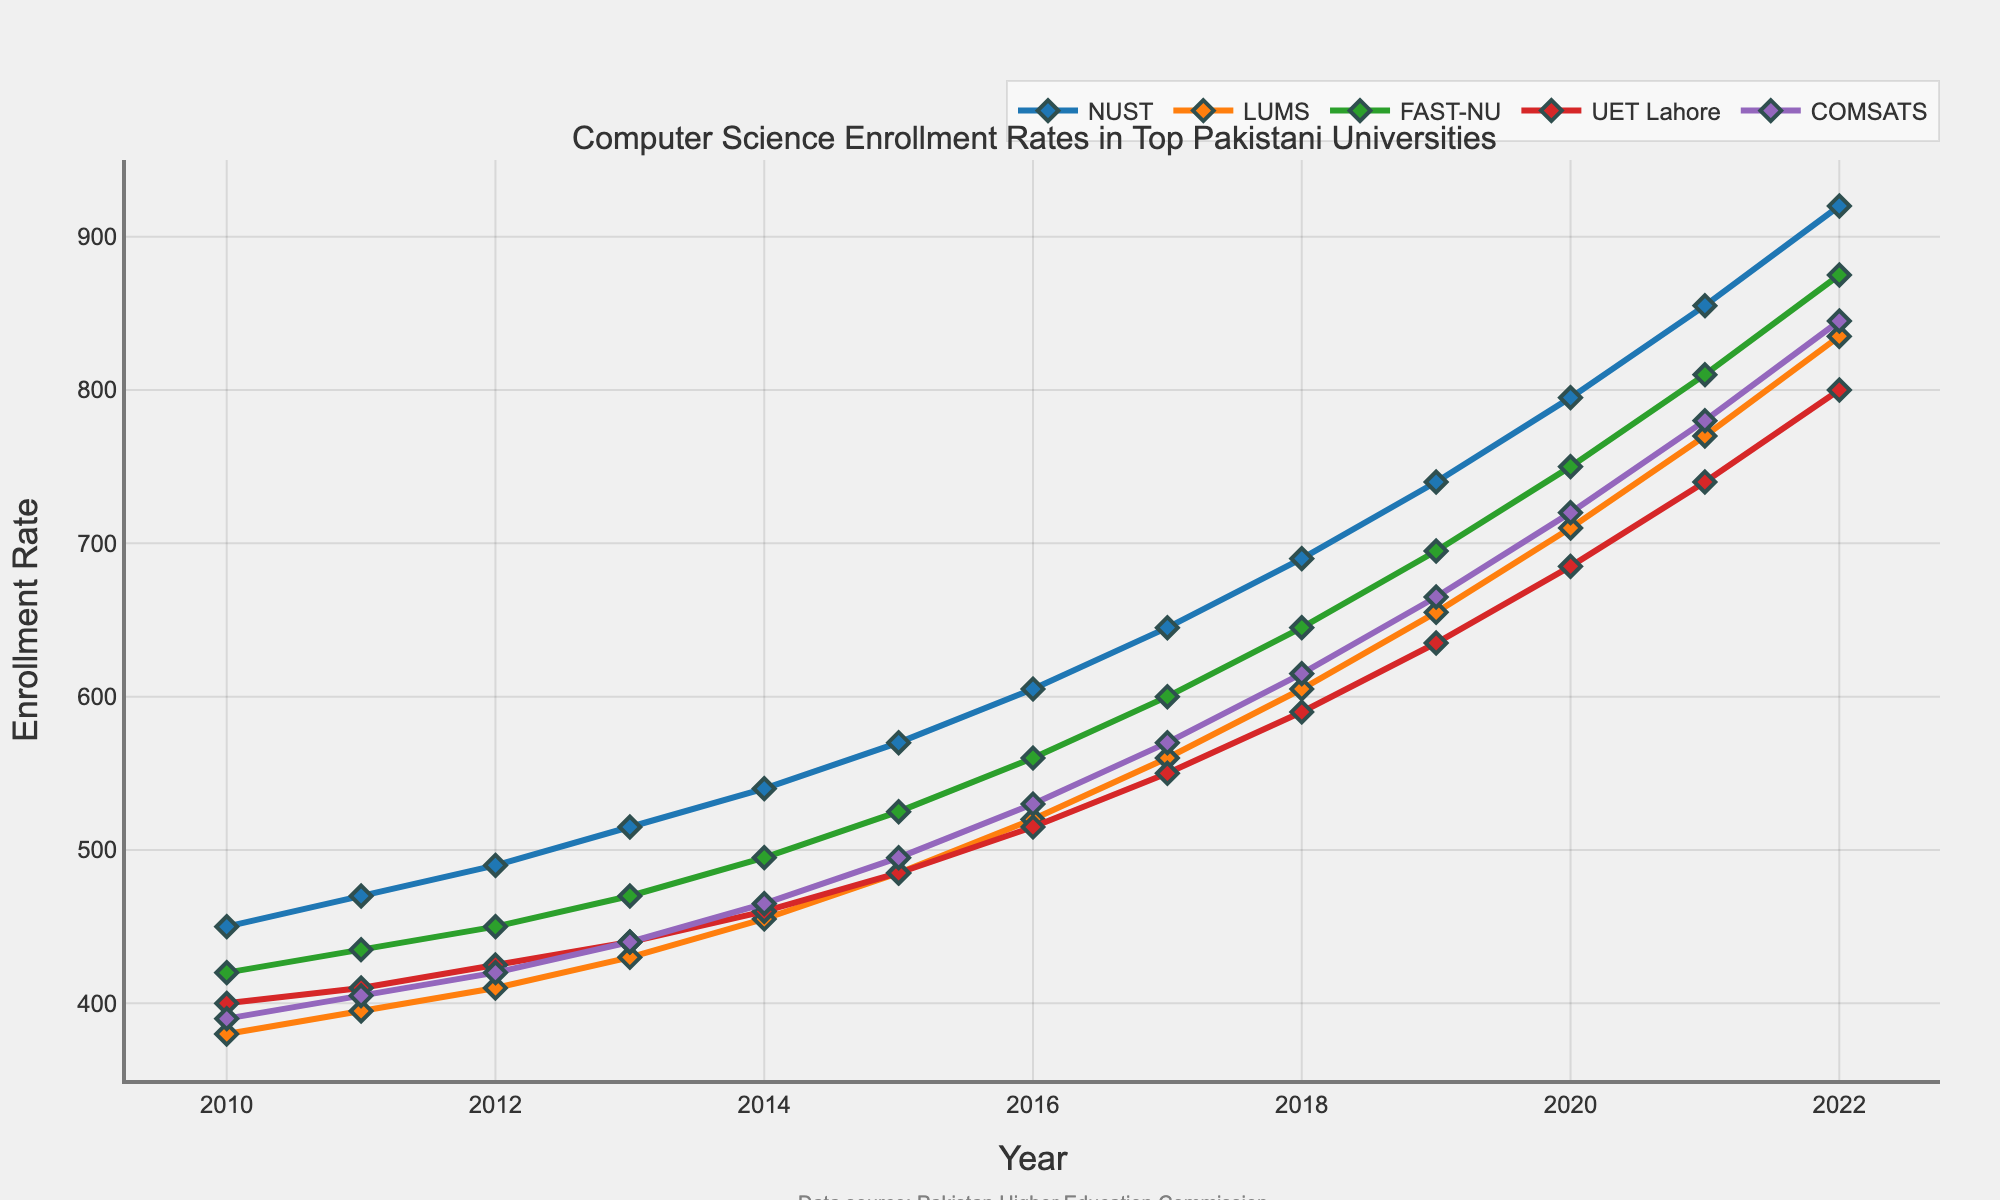Which university had the highest enrollment rate in 2010? By looking at the graph, NUST had the highest enrollment rate in 2010 compared to other universities.
Answer: NUST What is the general trend in enrollment rates for COMSATS from 2010 to 2022? The line representing COMSATS shows an upward trend, indicating that the enrollment rates have generally increased from 2010 to 2022.
Answer: Increasing In which year did LUMS surpass the enrollment rate of 500? By examining the line representing LUMS, it surpassed the enrollment rate of 500 in the year 2016.
Answer: 2016 Which university showed a sharp increase in enrollment between 2018 and 2019? The plot for NUST shows a steep incline between 2018 and 2019, indicating a sharp increase in enrollment.
Answer: NUST How does the enrollment rate for FAST-NU in 2015 compare to UET Lahore in 2015? By comparing the lines, FAST-NU had an enrollment rate of 525 in 2015 while UET Lahore had 485.
Answer: FAST-NU is higher than UET Lahore In which year did UET Lahore's enrollment reach 600? UET Lahore's enrollment rate reached 600 in 2017.
Answer: 2017 Which university had the least increase in enrollment from 2010 to 2022? By comparing the start and end points of each line, LUMS had the least increase in enrollment from 2010 to 2022.
Answer: LUMS On average, how much did the enrollment rate for NUST increase per year from 2010 to 2022? NUST's enrollment increased from 450 to 920, which is a total increase of 470 over 12 years. The average increase per year is 470/12 = 39.17.
Answer: 39.17 What's the difference in enrollment rates between COMSATS and LUMS in 2020? In 2020, COMSATS had an enrollment rate of 720, while LUMS had 710. The difference is 720 - 710 = 10.
Answer: 10 How many universities had enrollment rates greater than 800 in 2022? By looking at the endpoints of the lines for 2022, NUST, FAST-NU, and COMSATS had enrollment rates greater than 800.
Answer: 3 